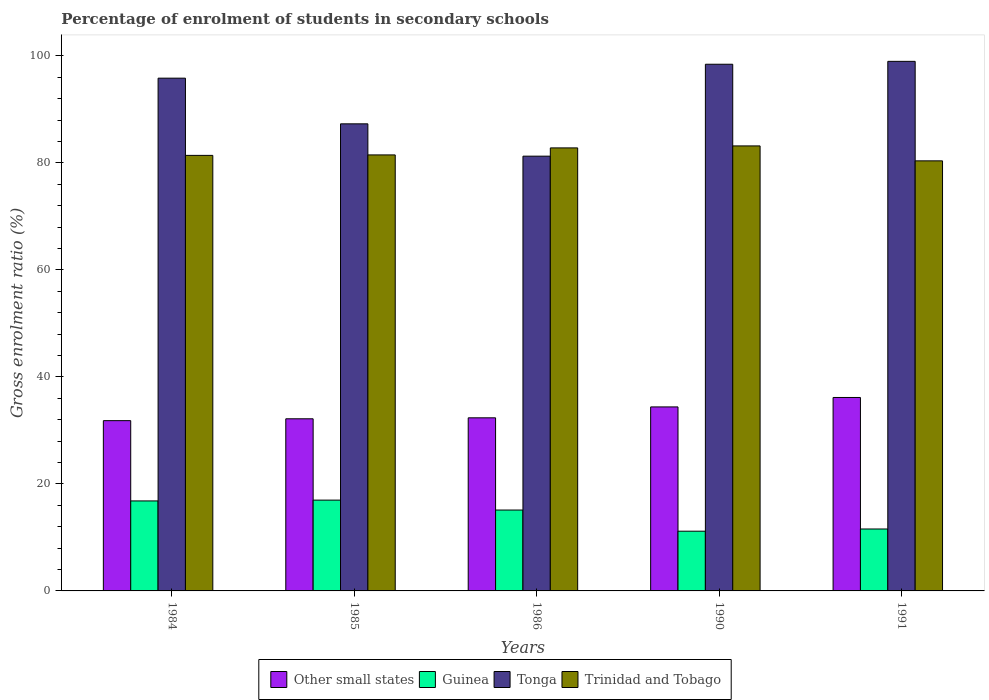How many groups of bars are there?
Offer a terse response. 5. Are the number of bars per tick equal to the number of legend labels?
Provide a succinct answer. Yes. Are the number of bars on each tick of the X-axis equal?
Give a very brief answer. Yes. How many bars are there on the 3rd tick from the right?
Ensure brevity in your answer.  4. In how many cases, is the number of bars for a given year not equal to the number of legend labels?
Make the answer very short. 0. What is the percentage of students enrolled in secondary schools in Tonga in 1984?
Offer a terse response. 95.83. Across all years, what is the maximum percentage of students enrolled in secondary schools in Guinea?
Your answer should be very brief. 16.97. Across all years, what is the minimum percentage of students enrolled in secondary schools in Other small states?
Offer a terse response. 31.82. In which year was the percentage of students enrolled in secondary schools in Tonga maximum?
Offer a very short reply. 1991. What is the total percentage of students enrolled in secondary schools in Trinidad and Tobago in the graph?
Your response must be concise. 409.23. What is the difference between the percentage of students enrolled in secondary schools in Other small states in 1984 and that in 1990?
Ensure brevity in your answer.  -2.57. What is the difference between the percentage of students enrolled in secondary schools in Trinidad and Tobago in 1986 and the percentage of students enrolled in secondary schools in Tonga in 1991?
Give a very brief answer. -16.18. What is the average percentage of students enrolled in secondary schools in Other small states per year?
Your answer should be very brief. 33.38. In the year 1991, what is the difference between the percentage of students enrolled in secondary schools in Tonga and percentage of students enrolled in secondary schools in Other small states?
Provide a succinct answer. 62.82. What is the ratio of the percentage of students enrolled in secondary schools in Tonga in 1986 to that in 1990?
Provide a short and direct response. 0.83. What is the difference between the highest and the second highest percentage of students enrolled in secondary schools in Other small states?
Provide a succinct answer. 1.76. What is the difference between the highest and the lowest percentage of students enrolled in secondary schools in Other small states?
Your answer should be compact. 4.33. In how many years, is the percentage of students enrolled in secondary schools in Other small states greater than the average percentage of students enrolled in secondary schools in Other small states taken over all years?
Your answer should be compact. 2. Is the sum of the percentage of students enrolled in secondary schools in Other small states in 1984 and 1991 greater than the maximum percentage of students enrolled in secondary schools in Guinea across all years?
Provide a short and direct response. Yes. Is it the case that in every year, the sum of the percentage of students enrolled in secondary schools in Other small states and percentage of students enrolled in secondary schools in Tonga is greater than the sum of percentage of students enrolled in secondary schools in Trinidad and Tobago and percentage of students enrolled in secondary schools in Guinea?
Provide a short and direct response. Yes. What does the 3rd bar from the left in 1990 represents?
Your response must be concise. Tonga. What does the 3rd bar from the right in 1986 represents?
Offer a terse response. Guinea. How many bars are there?
Your response must be concise. 20. How many years are there in the graph?
Provide a succinct answer. 5. Does the graph contain any zero values?
Your answer should be very brief. No. Where does the legend appear in the graph?
Provide a succinct answer. Bottom center. How are the legend labels stacked?
Ensure brevity in your answer.  Horizontal. What is the title of the graph?
Your answer should be compact. Percentage of enrolment of students in secondary schools. Does "Small states" appear as one of the legend labels in the graph?
Provide a succinct answer. No. What is the label or title of the Y-axis?
Offer a very short reply. Gross enrolment ratio (%). What is the Gross enrolment ratio (%) in Other small states in 1984?
Offer a terse response. 31.82. What is the Gross enrolment ratio (%) of Guinea in 1984?
Provide a short and direct response. 16.82. What is the Gross enrolment ratio (%) of Tonga in 1984?
Offer a very short reply. 95.83. What is the Gross enrolment ratio (%) in Trinidad and Tobago in 1984?
Provide a short and direct response. 81.4. What is the Gross enrolment ratio (%) of Other small states in 1985?
Offer a very short reply. 32.17. What is the Gross enrolment ratio (%) of Guinea in 1985?
Ensure brevity in your answer.  16.97. What is the Gross enrolment ratio (%) in Tonga in 1985?
Your response must be concise. 87.29. What is the Gross enrolment ratio (%) in Trinidad and Tobago in 1985?
Give a very brief answer. 81.49. What is the Gross enrolment ratio (%) of Other small states in 1986?
Give a very brief answer. 32.35. What is the Gross enrolment ratio (%) of Guinea in 1986?
Ensure brevity in your answer.  15.12. What is the Gross enrolment ratio (%) in Tonga in 1986?
Make the answer very short. 81.25. What is the Gross enrolment ratio (%) in Trinidad and Tobago in 1986?
Offer a very short reply. 82.8. What is the Gross enrolment ratio (%) of Other small states in 1990?
Provide a short and direct response. 34.39. What is the Gross enrolment ratio (%) in Guinea in 1990?
Make the answer very short. 11.16. What is the Gross enrolment ratio (%) of Tonga in 1990?
Give a very brief answer. 98.43. What is the Gross enrolment ratio (%) of Trinidad and Tobago in 1990?
Your response must be concise. 83.17. What is the Gross enrolment ratio (%) of Other small states in 1991?
Keep it short and to the point. 36.15. What is the Gross enrolment ratio (%) in Guinea in 1991?
Ensure brevity in your answer.  11.57. What is the Gross enrolment ratio (%) in Tonga in 1991?
Your answer should be very brief. 98.97. What is the Gross enrolment ratio (%) of Trinidad and Tobago in 1991?
Your response must be concise. 80.38. Across all years, what is the maximum Gross enrolment ratio (%) in Other small states?
Offer a very short reply. 36.15. Across all years, what is the maximum Gross enrolment ratio (%) of Guinea?
Offer a terse response. 16.97. Across all years, what is the maximum Gross enrolment ratio (%) of Tonga?
Your answer should be very brief. 98.97. Across all years, what is the maximum Gross enrolment ratio (%) of Trinidad and Tobago?
Your response must be concise. 83.17. Across all years, what is the minimum Gross enrolment ratio (%) of Other small states?
Offer a terse response. 31.82. Across all years, what is the minimum Gross enrolment ratio (%) in Guinea?
Offer a very short reply. 11.16. Across all years, what is the minimum Gross enrolment ratio (%) in Tonga?
Your answer should be compact. 81.25. Across all years, what is the minimum Gross enrolment ratio (%) of Trinidad and Tobago?
Your response must be concise. 80.38. What is the total Gross enrolment ratio (%) of Other small states in the graph?
Offer a very short reply. 166.88. What is the total Gross enrolment ratio (%) in Guinea in the graph?
Your response must be concise. 71.64. What is the total Gross enrolment ratio (%) of Tonga in the graph?
Provide a short and direct response. 461.78. What is the total Gross enrolment ratio (%) of Trinidad and Tobago in the graph?
Keep it short and to the point. 409.23. What is the difference between the Gross enrolment ratio (%) in Other small states in 1984 and that in 1985?
Provide a short and direct response. -0.35. What is the difference between the Gross enrolment ratio (%) in Guinea in 1984 and that in 1985?
Your response must be concise. -0.15. What is the difference between the Gross enrolment ratio (%) in Tonga in 1984 and that in 1985?
Your response must be concise. 8.54. What is the difference between the Gross enrolment ratio (%) of Trinidad and Tobago in 1984 and that in 1985?
Ensure brevity in your answer.  -0.09. What is the difference between the Gross enrolment ratio (%) in Other small states in 1984 and that in 1986?
Keep it short and to the point. -0.53. What is the difference between the Gross enrolment ratio (%) of Guinea in 1984 and that in 1986?
Make the answer very short. 1.7. What is the difference between the Gross enrolment ratio (%) in Tonga in 1984 and that in 1986?
Your answer should be compact. 14.58. What is the difference between the Gross enrolment ratio (%) in Trinidad and Tobago in 1984 and that in 1986?
Your response must be concise. -1.4. What is the difference between the Gross enrolment ratio (%) of Other small states in 1984 and that in 1990?
Give a very brief answer. -2.57. What is the difference between the Gross enrolment ratio (%) in Guinea in 1984 and that in 1990?
Keep it short and to the point. 5.66. What is the difference between the Gross enrolment ratio (%) in Tonga in 1984 and that in 1990?
Offer a very short reply. -2.6. What is the difference between the Gross enrolment ratio (%) in Trinidad and Tobago in 1984 and that in 1990?
Your answer should be compact. -1.77. What is the difference between the Gross enrolment ratio (%) of Other small states in 1984 and that in 1991?
Provide a short and direct response. -4.33. What is the difference between the Gross enrolment ratio (%) of Guinea in 1984 and that in 1991?
Offer a very short reply. 5.25. What is the difference between the Gross enrolment ratio (%) of Tonga in 1984 and that in 1991?
Your answer should be compact. -3.14. What is the difference between the Gross enrolment ratio (%) in Trinidad and Tobago in 1984 and that in 1991?
Provide a short and direct response. 1.02. What is the difference between the Gross enrolment ratio (%) in Other small states in 1985 and that in 1986?
Give a very brief answer. -0.18. What is the difference between the Gross enrolment ratio (%) in Guinea in 1985 and that in 1986?
Provide a short and direct response. 1.85. What is the difference between the Gross enrolment ratio (%) in Tonga in 1985 and that in 1986?
Offer a very short reply. 6.04. What is the difference between the Gross enrolment ratio (%) of Trinidad and Tobago in 1985 and that in 1986?
Offer a very short reply. -1.31. What is the difference between the Gross enrolment ratio (%) of Other small states in 1985 and that in 1990?
Provide a short and direct response. -2.22. What is the difference between the Gross enrolment ratio (%) in Guinea in 1985 and that in 1990?
Provide a short and direct response. 5.81. What is the difference between the Gross enrolment ratio (%) of Tonga in 1985 and that in 1990?
Offer a terse response. -11.14. What is the difference between the Gross enrolment ratio (%) in Trinidad and Tobago in 1985 and that in 1990?
Provide a succinct answer. -1.68. What is the difference between the Gross enrolment ratio (%) of Other small states in 1985 and that in 1991?
Offer a very short reply. -3.98. What is the difference between the Gross enrolment ratio (%) of Guinea in 1985 and that in 1991?
Give a very brief answer. 5.39. What is the difference between the Gross enrolment ratio (%) in Tonga in 1985 and that in 1991?
Keep it short and to the point. -11.68. What is the difference between the Gross enrolment ratio (%) in Trinidad and Tobago in 1985 and that in 1991?
Provide a succinct answer. 1.11. What is the difference between the Gross enrolment ratio (%) of Other small states in 1986 and that in 1990?
Make the answer very short. -2.04. What is the difference between the Gross enrolment ratio (%) in Guinea in 1986 and that in 1990?
Offer a very short reply. 3.95. What is the difference between the Gross enrolment ratio (%) of Tonga in 1986 and that in 1990?
Provide a short and direct response. -17.18. What is the difference between the Gross enrolment ratio (%) of Trinidad and Tobago in 1986 and that in 1990?
Offer a terse response. -0.37. What is the difference between the Gross enrolment ratio (%) in Other small states in 1986 and that in 1991?
Your response must be concise. -3.8. What is the difference between the Gross enrolment ratio (%) of Guinea in 1986 and that in 1991?
Your answer should be very brief. 3.54. What is the difference between the Gross enrolment ratio (%) of Tonga in 1986 and that in 1991?
Ensure brevity in your answer.  -17.72. What is the difference between the Gross enrolment ratio (%) in Trinidad and Tobago in 1986 and that in 1991?
Your answer should be very brief. 2.42. What is the difference between the Gross enrolment ratio (%) of Other small states in 1990 and that in 1991?
Provide a short and direct response. -1.76. What is the difference between the Gross enrolment ratio (%) in Guinea in 1990 and that in 1991?
Offer a very short reply. -0.41. What is the difference between the Gross enrolment ratio (%) in Tonga in 1990 and that in 1991?
Give a very brief answer. -0.54. What is the difference between the Gross enrolment ratio (%) of Trinidad and Tobago in 1990 and that in 1991?
Provide a succinct answer. 2.79. What is the difference between the Gross enrolment ratio (%) in Other small states in 1984 and the Gross enrolment ratio (%) in Guinea in 1985?
Offer a very short reply. 14.85. What is the difference between the Gross enrolment ratio (%) of Other small states in 1984 and the Gross enrolment ratio (%) of Tonga in 1985?
Your response must be concise. -55.47. What is the difference between the Gross enrolment ratio (%) of Other small states in 1984 and the Gross enrolment ratio (%) of Trinidad and Tobago in 1985?
Provide a succinct answer. -49.67. What is the difference between the Gross enrolment ratio (%) in Guinea in 1984 and the Gross enrolment ratio (%) in Tonga in 1985?
Give a very brief answer. -70.47. What is the difference between the Gross enrolment ratio (%) in Guinea in 1984 and the Gross enrolment ratio (%) in Trinidad and Tobago in 1985?
Offer a terse response. -64.67. What is the difference between the Gross enrolment ratio (%) in Tonga in 1984 and the Gross enrolment ratio (%) in Trinidad and Tobago in 1985?
Offer a terse response. 14.34. What is the difference between the Gross enrolment ratio (%) in Other small states in 1984 and the Gross enrolment ratio (%) in Guinea in 1986?
Keep it short and to the point. 16.71. What is the difference between the Gross enrolment ratio (%) in Other small states in 1984 and the Gross enrolment ratio (%) in Tonga in 1986?
Offer a terse response. -49.43. What is the difference between the Gross enrolment ratio (%) in Other small states in 1984 and the Gross enrolment ratio (%) in Trinidad and Tobago in 1986?
Offer a very short reply. -50.97. What is the difference between the Gross enrolment ratio (%) of Guinea in 1984 and the Gross enrolment ratio (%) of Tonga in 1986?
Make the answer very short. -64.43. What is the difference between the Gross enrolment ratio (%) in Guinea in 1984 and the Gross enrolment ratio (%) in Trinidad and Tobago in 1986?
Give a very brief answer. -65.98. What is the difference between the Gross enrolment ratio (%) of Tonga in 1984 and the Gross enrolment ratio (%) of Trinidad and Tobago in 1986?
Make the answer very short. 13.03. What is the difference between the Gross enrolment ratio (%) of Other small states in 1984 and the Gross enrolment ratio (%) of Guinea in 1990?
Offer a terse response. 20.66. What is the difference between the Gross enrolment ratio (%) in Other small states in 1984 and the Gross enrolment ratio (%) in Tonga in 1990?
Keep it short and to the point. -66.61. What is the difference between the Gross enrolment ratio (%) of Other small states in 1984 and the Gross enrolment ratio (%) of Trinidad and Tobago in 1990?
Your answer should be very brief. -51.35. What is the difference between the Gross enrolment ratio (%) of Guinea in 1984 and the Gross enrolment ratio (%) of Tonga in 1990?
Your answer should be compact. -81.61. What is the difference between the Gross enrolment ratio (%) in Guinea in 1984 and the Gross enrolment ratio (%) in Trinidad and Tobago in 1990?
Give a very brief answer. -66.35. What is the difference between the Gross enrolment ratio (%) of Tonga in 1984 and the Gross enrolment ratio (%) of Trinidad and Tobago in 1990?
Provide a succinct answer. 12.66. What is the difference between the Gross enrolment ratio (%) of Other small states in 1984 and the Gross enrolment ratio (%) of Guinea in 1991?
Your answer should be very brief. 20.25. What is the difference between the Gross enrolment ratio (%) of Other small states in 1984 and the Gross enrolment ratio (%) of Tonga in 1991?
Provide a short and direct response. -67.15. What is the difference between the Gross enrolment ratio (%) in Other small states in 1984 and the Gross enrolment ratio (%) in Trinidad and Tobago in 1991?
Offer a terse response. -48.55. What is the difference between the Gross enrolment ratio (%) of Guinea in 1984 and the Gross enrolment ratio (%) of Tonga in 1991?
Provide a succinct answer. -82.15. What is the difference between the Gross enrolment ratio (%) in Guinea in 1984 and the Gross enrolment ratio (%) in Trinidad and Tobago in 1991?
Keep it short and to the point. -63.56. What is the difference between the Gross enrolment ratio (%) of Tonga in 1984 and the Gross enrolment ratio (%) of Trinidad and Tobago in 1991?
Offer a very short reply. 15.46. What is the difference between the Gross enrolment ratio (%) of Other small states in 1985 and the Gross enrolment ratio (%) of Guinea in 1986?
Your response must be concise. 17.05. What is the difference between the Gross enrolment ratio (%) in Other small states in 1985 and the Gross enrolment ratio (%) in Tonga in 1986?
Make the answer very short. -49.08. What is the difference between the Gross enrolment ratio (%) in Other small states in 1985 and the Gross enrolment ratio (%) in Trinidad and Tobago in 1986?
Give a very brief answer. -50.63. What is the difference between the Gross enrolment ratio (%) of Guinea in 1985 and the Gross enrolment ratio (%) of Tonga in 1986?
Provide a succinct answer. -64.28. What is the difference between the Gross enrolment ratio (%) in Guinea in 1985 and the Gross enrolment ratio (%) in Trinidad and Tobago in 1986?
Your answer should be very brief. -65.83. What is the difference between the Gross enrolment ratio (%) in Tonga in 1985 and the Gross enrolment ratio (%) in Trinidad and Tobago in 1986?
Your response must be concise. 4.5. What is the difference between the Gross enrolment ratio (%) of Other small states in 1985 and the Gross enrolment ratio (%) of Guinea in 1990?
Your answer should be compact. 21.01. What is the difference between the Gross enrolment ratio (%) in Other small states in 1985 and the Gross enrolment ratio (%) in Tonga in 1990?
Give a very brief answer. -66.26. What is the difference between the Gross enrolment ratio (%) of Other small states in 1985 and the Gross enrolment ratio (%) of Trinidad and Tobago in 1990?
Your response must be concise. -51. What is the difference between the Gross enrolment ratio (%) in Guinea in 1985 and the Gross enrolment ratio (%) in Tonga in 1990?
Your answer should be compact. -81.46. What is the difference between the Gross enrolment ratio (%) of Guinea in 1985 and the Gross enrolment ratio (%) of Trinidad and Tobago in 1990?
Your answer should be compact. -66.2. What is the difference between the Gross enrolment ratio (%) of Tonga in 1985 and the Gross enrolment ratio (%) of Trinidad and Tobago in 1990?
Provide a short and direct response. 4.13. What is the difference between the Gross enrolment ratio (%) of Other small states in 1985 and the Gross enrolment ratio (%) of Guinea in 1991?
Your answer should be compact. 20.59. What is the difference between the Gross enrolment ratio (%) in Other small states in 1985 and the Gross enrolment ratio (%) in Tonga in 1991?
Provide a short and direct response. -66.8. What is the difference between the Gross enrolment ratio (%) of Other small states in 1985 and the Gross enrolment ratio (%) of Trinidad and Tobago in 1991?
Provide a short and direct response. -48.21. What is the difference between the Gross enrolment ratio (%) of Guinea in 1985 and the Gross enrolment ratio (%) of Tonga in 1991?
Offer a terse response. -82. What is the difference between the Gross enrolment ratio (%) of Guinea in 1985 and the Gross enrolment ratio (%) of Trinidad and Tobago in 1991?
Offer a very short reply. -63.41. What is the difference between the Gross enrolment ratio (%) in Tonga in 1985 and the Gross enrolment ratio (%) in Trinidad and Tobago in 1991?
Provide a short and direct response. 6.92. What is the difference between the Gross enrolment ratio (%) of Other small states in 1986 and the Gross enrolment ratio (%) of Guinea in 1990?
Your answer should be compact. 21.19. What is the difference between the Gross enrolment ratio (%) in Other small states in 1986 and the Gross enrolment ratio (%) in Tonga in 1990?
Your response must be concise. -66.08. What is the difference between the Gross enrolment ratio (%) in Other small states in 1986 and the Gross enrolment ratio (%) in Trinidad and Tobago in 1990?
Keep it short and to the point. -50.82. What is the difference between the Gross enrolment ratio (%) in Guinea in 1986 and the Gross enrolment ratio (%) in Tonga in 1990?
Give a very brief answer. -83.32. What is the difference between the Gross enrolment ratio (%) of Guinea in 1986 and the Gross enrolment ratio (%) of Trinidad and Tobago in 1990?
Give a very brief answer. -68.05. What is the difference between the Gross enrolment ratio (%) in Tonga in 1986 and the Gross enrolment ratio (%) in Trinidad and Tobago in 1990?
Offer a very short reply. -1.92. What is the difference between the Gross enrolment ratio (%) of Other small states in 1986 and the Gross enrolment ratio (%) of Guinea in 1991?
Your response must be concise. 20.78. What is the difference between the Gross enrolment ratio (%) of Other small states in 1986 and the Gross enrolment ratio (%) of Tonga in 1991?
Ensure brevity in your answer.  -66.62. What is the difference between the Gross enrolment ratio (%) of Other small states in 1986 and the Gross enrolment ratio (%) of Trinidad and Tobago in 1991?
Your answer should be very brief. -48.02. What is the difference between the Gross enrolment ratio (%) of Guinea in 1986 and the Gross enrolment ratio (%) of Tonga in 1991?
Your answer should be compact. -83.86. What is the difference between the Gross enrolment ratio (%) of Guinea in 1986 and the Gross enrolment ratio (%) of Trinidad and Tobago in 1991?
Keep it short and to the point. -65.26. What is the difference between the Gross enrolment ratio (%) of Tonga in 1986 and the Gross enrolment ratio (%) of Trinidad and Tobago in 1991?
Ensure brevity in your answer.  0.88. What is the difference between the Gross enrolment ratio (%) of Other small states in 1990 and the Gross enrolment ratio (%) of Guinea in 1991?
Your answer should be very brief. 22.81. What is the difference between the Gross enrolment ratio (%) of Other small states in 1990 and the Gross enrolment ratio (%) of Tonga in 1991?
Provide a short and direct response. -64.58. What is the difference between the Gross enrolment ratio (%) of Other small states in 1990 and the Gross enrolment ratio (%) of Trinidad and Tobago in 1991?
Offer a very short reply. -45.99. What is the difference between the Gross enrolment ratio (%) in Guinea in 1990 and the Gross enrolment ratio (%) in Tonga in 1991?
Give a very brief answer. -87.81. What is the difference between the Gross enrolment ratio (%) of Guinea in 1990 and the Gross enrolment ratio (%) of Trinidad and Tobago in 1991?
Give a very brief answer. -69.21. What is the difference between the Gross enrolment ratio (%) of Tonga in 1990 and the Gross enrolment ratio (%) of Trinidad and Tobago in 1991?
Provide a short and direct response. 18.06. What is the average Gross enrolment ratio (%) in Other small states per year?
Give a very brief answer. 33.38. What is the average Gross enrolment ratio (%) in Guinea per year?
Ensure brevity in your answer.  14.33. What is the average Gross enrolment ratio (%) in Tonga per year?
Your answer should be compact. 92.36. What is the average Gross enrolment ratio (%) in Trinidad and Tobago per year?
Provide a succinct answer. 81.85. In the year 1984, what is the difference between the Gross enrolment ratio (%) in Other small states and Gross enrolment ratio (%) in Guinea?
Your answer should be very brief. 15. In the year 1984, what is the difference between the Gross enrolment ratio (%) of Other small states and Gross enrolment ratio (%) of Tonga?
Make the answer very short. -64.01. In the year 1984, what is the difference between the Gross enrolment ratio (%) of Other small states and Gross enrolment ratio (%) of Trinidad and Tobago?
Offer a very short reply. -49.58. In the year 1984, what is the difference between the Gross enrolment ratio (%) in Guinea and Gross enrolment ratio (%) in Tonga?
Your answer should be very brief. -79.01. In the year 1984, what is the difference between the Gross enrolment ratio (%) in Guinea and Gross enrolment ratio (%) in Trinidad and Tobago?
Offer a terse response. -64.58. In the year 1984, what is the difference between the Gross enrolment ratio (%) of Tonga and Gross enrolment ratio (%) of Trinidad and Tobago?
Ensure brevity in your answer.  14.43. In the year 1985, what is the difference between the Gross enrolment ratio (%) in Other small states and Gross enrolment ratio (%) in Guinea?
Offer a terse response. 15.2. In the year 1985, what is the difference between the Gross enrolment ratio (%) in Other small states and Gross enrolment ratio (%) in Tonga?
Ensure brevity in your answer.  -55.13. In the year 1985, what is the difference between the Gross enrolment ratio (%) in Other small states and Gross enrolment ratio (%) in Trinidad and Tobago?
Make the answer very short. -49.32. In the year 1985, what is the difference between the Gross enrolment ratio (%) in Guinea and Gross enrolment ratio (%) in Tonga?
Your answer should be very brief. -70.33. In the year 1985, what is the difference between the Gross enrolment ratio (%) in Guinea and Gross enrolment ratio (%) in Trinidad and Tobago?
Offer a very short reply. -64.52. In the year 1985, what is the difference between the Gross enrolment ratio (%) of Tonga and Gross enrolment ratio (%) of Trinidad and Tobago?
Give a very brief answer. 5.81. In the year 1986, what is the difference between the Gross enrolment ratio (%) of Other small states and Gross enrolment ratio (%) of Guinea?
Your answer should be very brief. 17.24. In the year 1986, what is the difference between the Gross enrolment ratio (%) in Other small states and Gross enrolment ratio (%) in Tonga?
Your answer should be compact. -48.9. In the year 1986, what is the difference between the Gross enrolment ratio (%) of Other small states and Gross enrolment ratio (%) of Trinidad and Tobago?
Provide a short and direct response. -50.45. In the year 1986, what is the difference between the Gross enrolment ratio (%) in Guinea and Gross enrolment ratio (%) in Tonga?
Make the answer very short. -66.14. In the year 1986, what is the difference between the Gross enrolment ratio (%) in Guinea and Gross enrolment ratio (%) in Trinidad and Tobago?
Your answer should be compact. -67.68. In the year 1986, what is the difference between the Gross enrolment ratio (%) in Tonga and Gross enrolment ratio (%) in Trinidad and Tobago?
Ensure brevity in your answer.  -1.54. In the year 1990, what is the difference between the Gross enrolment ratio (%) of Other small states and Gross enrolment ratio (%) of Guinea?
Offer a very short reply. 23.23. In the year 1990, what is the difference between the Gross enrolment ratio (%) in Other small states and Gross enrolment ratio (%) in Tonga?
Provide a short and direct response. -64.04. In the year 1990, what is the difference between the Gross enrolment ratio (%) of Other small states and Gross enrolment ratio (%) of Trinidad and Tobago?
Your response must be concise. -48.78. In the year 1990, what is the difference between the Gross enrolment ratio (%) of Guinea and Gross enrolment ratio (%) of Tonga?
Provide a short and direct response. -87.27. In the year 1990, what is the difference between the Gross enrolment ratio (%) in Guinea and Gross enrolment ratio (%) in Trinidad and Tobago?
Provide a succinct answer. -72.01. In the year 1990, what is the difference between the Gross enrolment ratio (%) of Tonga and Gross enrolment ratio (%) of Trinidad and Tobago?
Ensure brevity in your answer.  15.26. In the year 1991, what is the difference between the Gross enrolment ratio (%) in Other small states and Gross enrolment ratio (%) in Guinea?
Give a very brief answer. 24.58. In the year 1991, what is the difference between the Gross enrolment ratio (%) in Other small states and Gross enrolment ratio (%) in Tonga?
Your answer should be compact. -62.82. In the year 1991, what is the difference between the Gross enrolment ratio (%) of Other small states and Gross enrolment ratio (%) of Trinidad and Tobago?
Your answer should be very brief. -44.22. In the year 1991, what is the difference between the Gross enrolment ratio (%) of Guinea and Gross enrolment ratio (%) of Tonga?
Give a very brief answer. -87.4. In the year 1991, what is the difference between the Gross enrolment ratio (%) in Guinea and Gross enrolment ratio (%) in Trinidad and Tobago?
Make the answer very short. -68.8. In the year 1991, what is the difference between the Gross enrolment ratio (%) in Tonga and Gross enrolment ratio (%) in Trinidad and Tobago?
Ensure brevity in your answer.  18.6. What is the ratio of the Gross enrolment ratio (%) of Other small states in 1984 to that in 1985?
Provide a succinct answer. 0.99. What is the ratio of the Gross enrolment ratio (%) in Guinea in 1984 to that in 1985?
Ensure brevity in your answer.  0.99. What is the ratio of the Gross enrolment ratio (%) of Tonga in 1984 to that in 1985?
Ensure brevity in your answer.  1.1. What is the ratio of the Gross enrolment ratio (%) in Trinidad and Tobago in 1984 to that in 1985?
Your answer should be very brief. 1. What is the ratio of the Gross enrolment ratio (%) in Other small states in 1984 to that in 1986?
Provide a succinct answer. 0.98. What is the ratio of the Gross enrolment ratio (%) in Guinea in 1984 to that in 1986?
Provide a short and direct response. 1.11. What is the ratio of the Gross enrolment ratio (%) of Tonga in 1984 to that in 1986?
Give a very brief answer. 1.18. What is the ratio of the Gross enrolment ratio (%) in Trinidad and Tobago in 1984 to that in 1986?
Your response must be concise. 0.98. What is the ratio of the Gross enrolment ratio (%) of Other small states in 1984 to that in 1990?
Provide a short and direct response. 0.93. What is the ratio of the Gross enrolment ratio (%) in Guinea in 1984 to that in 1990?
Give a very brief answer. 1.51. What is the ratio of the Gross enrolment ratio (%) of Tonga in 1984 to that in 1990?
Your answer should be very brief. 0.97. What is the ratio of the Gross enrolment ratio (%) of Trinidad and Tobago in 1984 to that in 1990?
Offer a very short reply. 0.98. What is the ratio of the Gross enrolment ratio (%) in Other small states in 1984 to that in 1991?
Keep it short and to the point. 0.88. What is the ratio of the Gross enrolment ratio (%) in Guinea in 1984 to that in 1991?
Offer a very short reply. 1.45. What is the ratio of the Gross enrolment ratio (%) of Tonga in 1984 to that in 1991?
Offer a very short reply. 0.97. What is the ratio of the Gross enrolment ratio (%) in Trinidad and Tobago in 1984 to that in 1991?
Your answer should be very brief. 1.01. What is the ratio of the Gross enrolment ratio (%) in Guinea in 1985 to that in 1986?
Keep it short and to the point. 1.12. What is the ratio of the Gross enrolment ratio (%) of Tonga in 1985 to that in 1986?
Provide a succinct answer. 1.07. What is the ratio of the Gross enrolment ratio (%) in Trinidad and Tobago in 1985 to that in 1986?
Your answer should be compact. 0.98. What is the ratio of the Gross enrolment ratio (%) in Other small states in 1985 to that in 1990?
Offer a very short reply. 0.94. What is the ratio of the Gross enrolment ratio (%) of Guinea in 1985 to that in 1990?
Offer a very short reply. 1.52. What is the ratio of the Gross enrolment ratio (%) of Tonga in 1985 to that in 1990?
Ensure brevity in your answer.  0.89. What is the ratio of the Gross enrolment ratio (%) in Trinidad and Tobago in 1985 to that in 1990?
Provide a succinct answer. 0.98. What is the ratio of the Gross enrolment ratio (%) in Other small states in 1985 to that in 1991?
Make the answer very short. 0.89. What is the ratio of the Gross enrolment ratio (%) of Guinea in 1985 to that in 1991?
Give a very brief answer. 1.47. What is the ratio of the Gross enrolment ratio (%) in Tonga in 1985 to that in 1991?
Ensure brevity in your answer.  0.88. What is the ratio of the Gross enrolment ratio (%) in Trinidad and Tobago in 1985 to that in 1991?
Keep it short and to the point. 1.01. What is the ratio of the Gross enrolment ratio (%) in Other small states in 1986 to that in 1990?
Offer a very short reply. 0.94. What is the ratio of the Gross enrolment ratio (%) in Guinea in 1986 to that in 1990?
Ensure brevity in your answer.  1.35. What is the ratio of the Gross enrolment ratio (%) in Tonga in 1986 to that in 1990?
Ensure brevity in your answer.  0.83. What is the ratio of the Gross enrolment ratio (%) of Other small states in 1986 to that in 1991?
Ensure brevity in your answer.  0.89. What is the ratio of the Gross enrolment ratio (%) of Guinea in 1986 to that in 1991?
Your answer should be very brief. 1.31. What is the ratio of the Gross enrolment ratio (%) in Tonga in 1986 to that in 1991?
Provide a succinct answer. 0.82. What is the ratio of the Gross enrolment ratio (%) of Trinidad and Tobago in 1986 to that in 1991?
Ensure brevity in your answer.  1.03. What is the ratio of the Gross enrolment ratio (%) of Other small states in 1990 to that in 1991?
Give a very brief answer. 0.95. What is the ratio of the Gross enrolment ratio (%) in Guinea in 1990 to that in 1991?
Make the answer very short. 0.96. What is the ratio of the Gross enrolment ratio (%) in Tonga in 1990 to that in 1991?
Your answer should be very brief. 0.99. What is the ratio of the Gross enrolment ratio (%) of Trinidad and Tobago in 1990 to that in 1991?
Your answer should be very brief. 1.03. What is the difference between the highest and the second highest Gross enrolment ratio (%) of Other small states?
Keep it short and to the point. 1.76. What is the difference between the highest and the second highest Gross enrolment ratio (%) in Guinea?
Your answer should be compact. 0.15. What is the difference between the highest and the second highest Gross enrolment ratio (%) of Tonga?
Offer a terse response. 0.54. What is the difference between the highest and the second highest Gross enrolment ratio (%) of Trinidad and Tobago?
Provide a succinct answer. 0.37. What is the difference between the highest and the lowest Gross enrolment ratio (%) in Other small states?
Make the answer very short. 4.33. What is the difference between the highest and the lowest Gross enrolment ratio (%) of Guinea?
Provide a succinct answer. 5.81. What is the difference between the highest and the lowest Gross enrolment ratio (%) of Tonga?
Offer a very short reply. 17.72. What is the difference between the highest and the lowest Gross enrolment ratio (%) of Trinidad and Tobago?
Offer a very short reply. 2.79. 